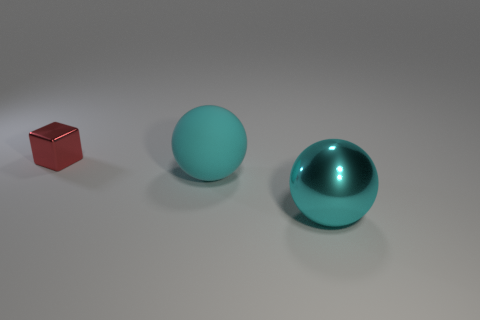Add 1 big shiny balls. How many objects exist? 4 Subtract all balls. How many objects are left? 1 Add 2 cyan metallic balls. How many cyan metallic balls exist? 3 Subtract 0 red cylinders. How many objects are left? 3 Subtract all big metallic balls. Subtract all red blocks. How many objects are left? 1 Add 1 large matte spheres. How many large matte spheres are left? 2 